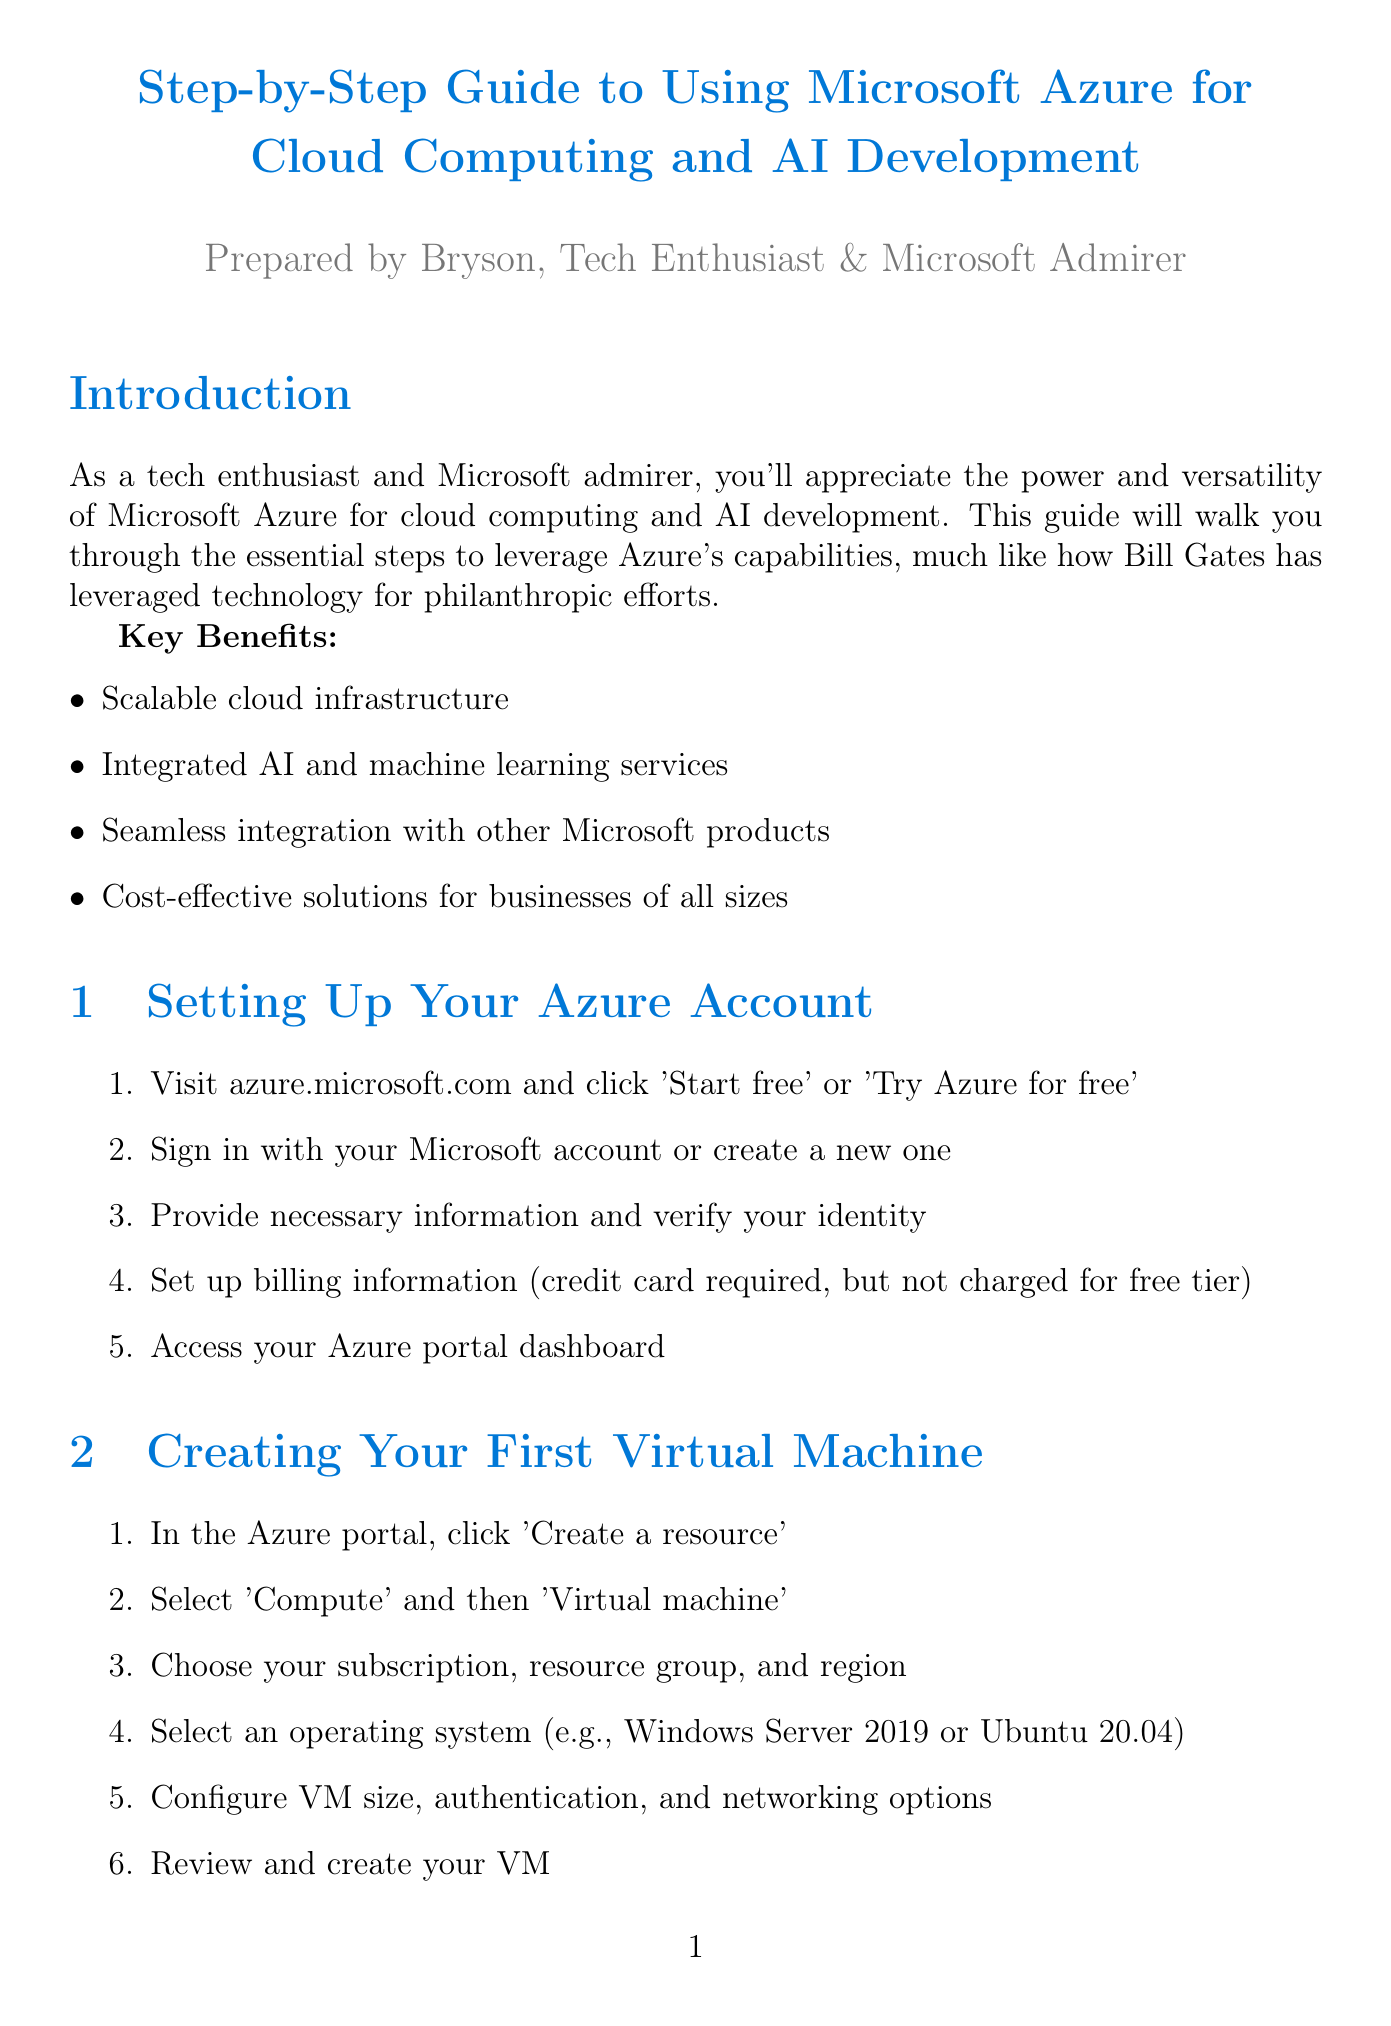What is the title of the document? The title is the main heading of the document, which provides an overview of its content.
Answer: Step-by-Step Guide to Using Microsoft Azure for Cloud Computing and AI Development What is the first step to set up an Azure account? The first step outlines the action to take when starting the account setup process.
Answer: Visit azure.microsoft.com and click 'Start free' or 'Try Azure for free' Which service helps in developing intelligent bots? This question targets specific Azure services mentioned in the document, focusing on AI capabilities.
Answer: Azure Bot Service How many steps are listed for creating your first virtual machine? The number of steps gives an idea of the complexity or simplicity of the task.
Answer: Six What is a key benefit of using Microsoft Azure? This is a general question that seeks to highlight the advantages of the platform.
Answer: Scalable cloud infrastructure What is the purpose of Azure Monitor? This question requires understanding the functionality of one of the tools listed in the document.
Answer: Comprehensive solution for collecting, analyzing, and acting on telemetry from cloud and on-premises environments Which initiative is associated with using Azure AI for humanitarian causes? This question connects specific programs with broader philanthropic goals mentioned in the document.
Answer: Microsoft AI for Good What must you set up when creating an Azure Machine Learning workspace? This highlights an essential requirement for setting up an operational environment.
Answer: Development environment What best practice involves secret management in Azure? This relates to security practices recommended for protecting information in the Azure environment.
Answer: Use Azure Key Vault for secure secret management 